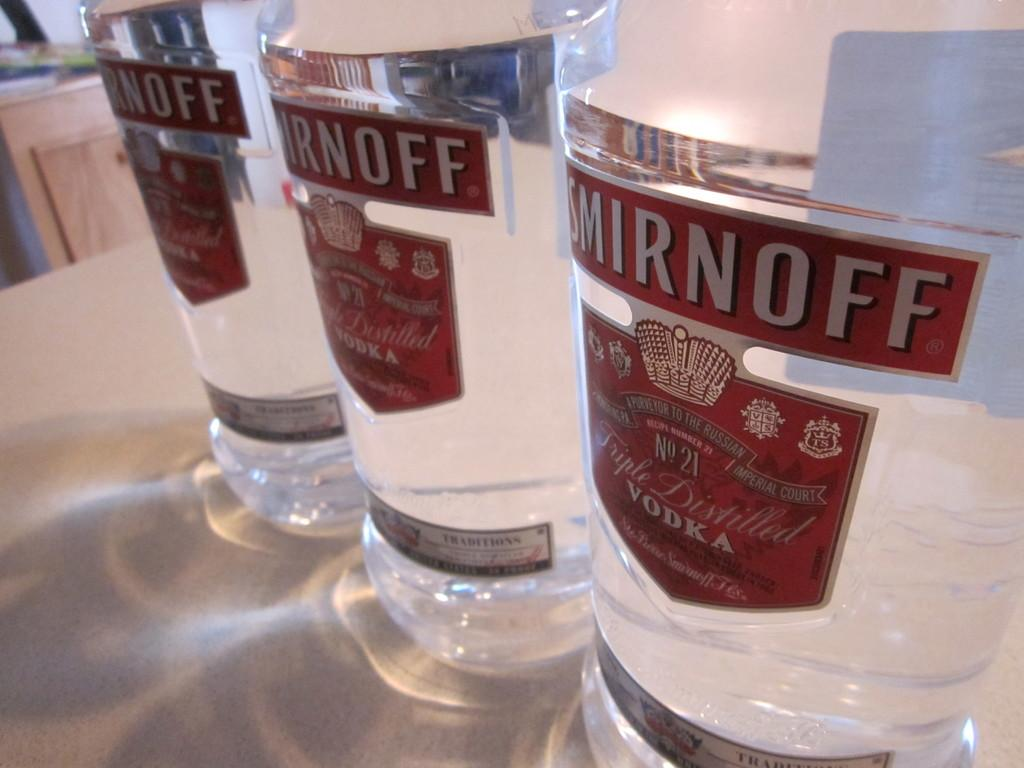<image>
Summarize the visual content of the image. three bottles labeled as smirnoff next to one another 